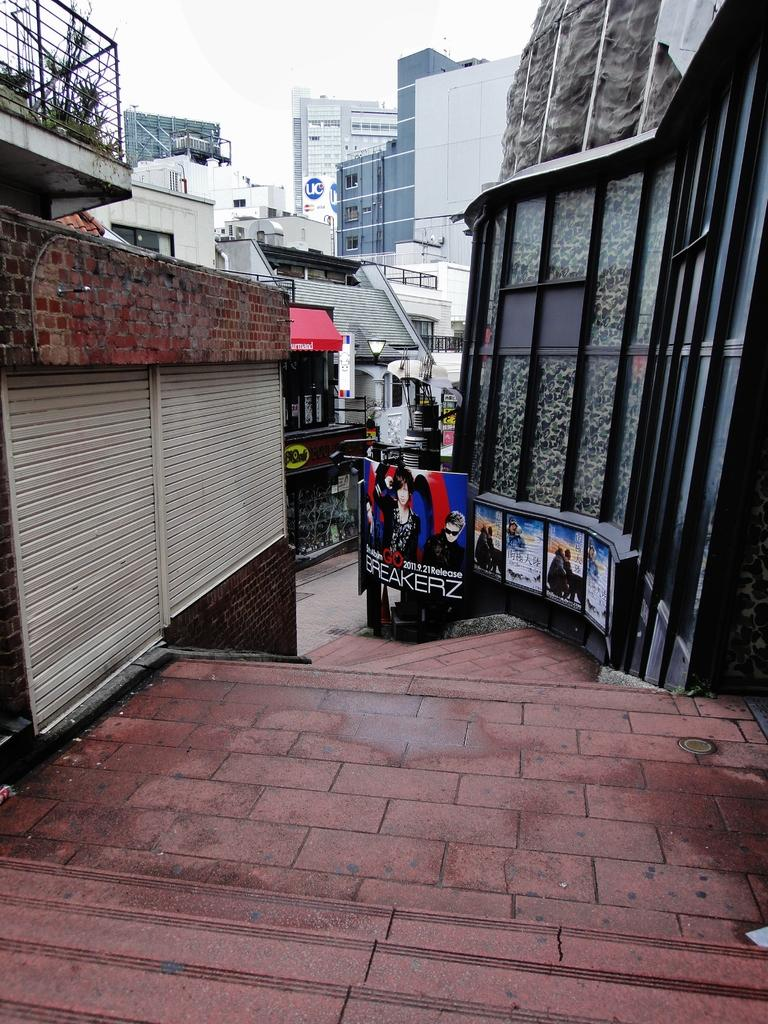What is the main feature in the center of the image? There are stairs in the center of the image. What can be seen in the background of the image? There are buildings and the sky visible in the background of the image. How many passengers are sitting on the chin of the person in the image? There is no person or chin present in the image; it features stairs and buildings in the background. 